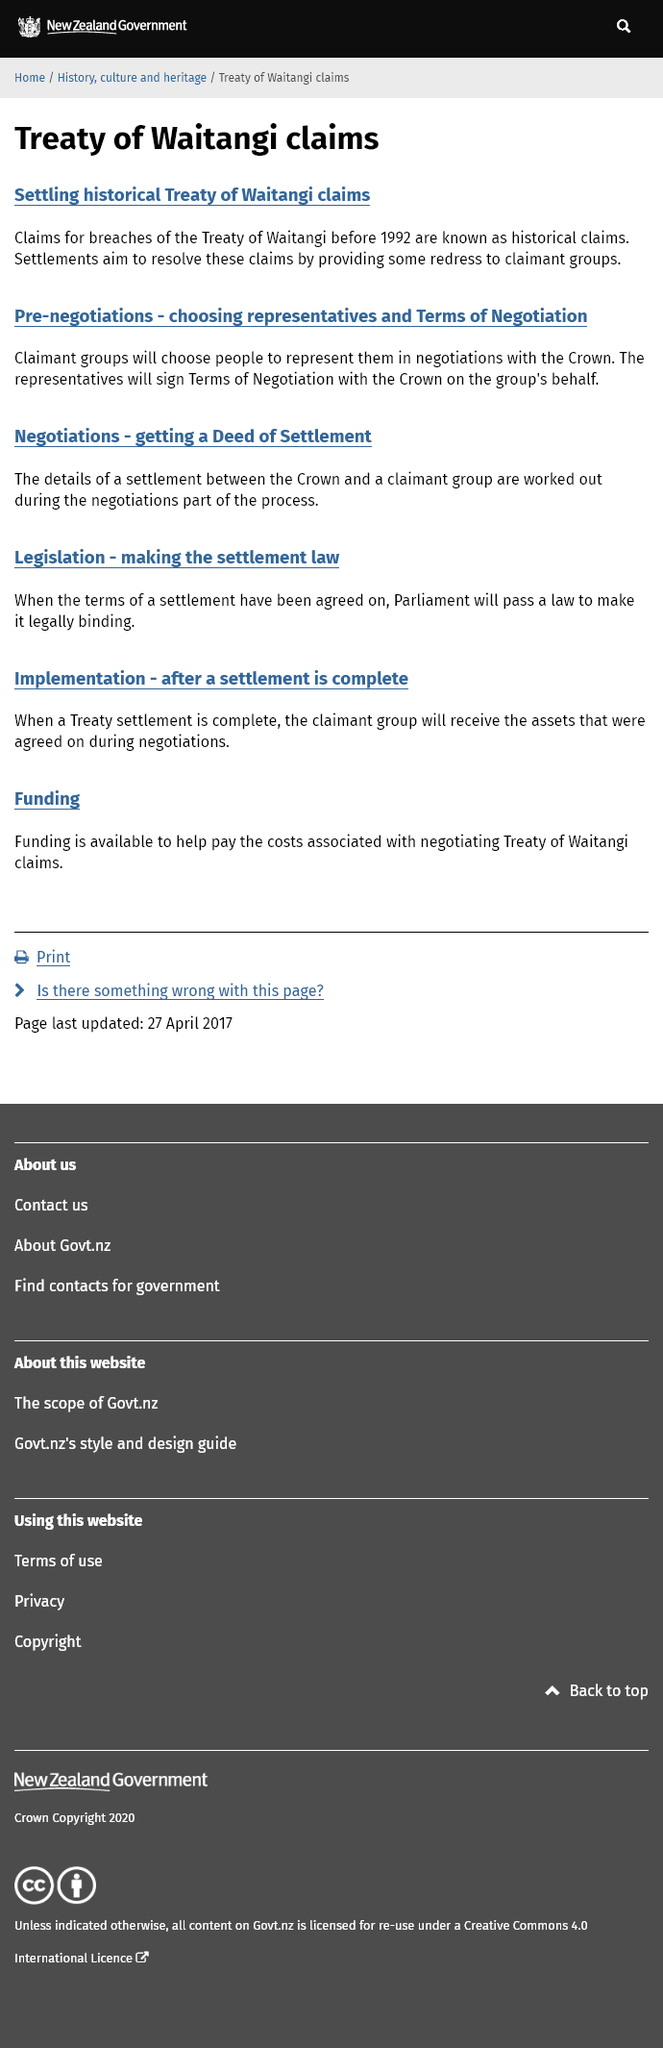Outline some significant characteristics in this image. The Treaty of Waitangi claims that existed prior to 1992 are known as historical claims. Claims for breaches of the Treaty of Waitangi can only be made before 1992. In settling claims, the aim is to provide redress to claimants groups, thereby resolving the underlying issues they may be facing. 